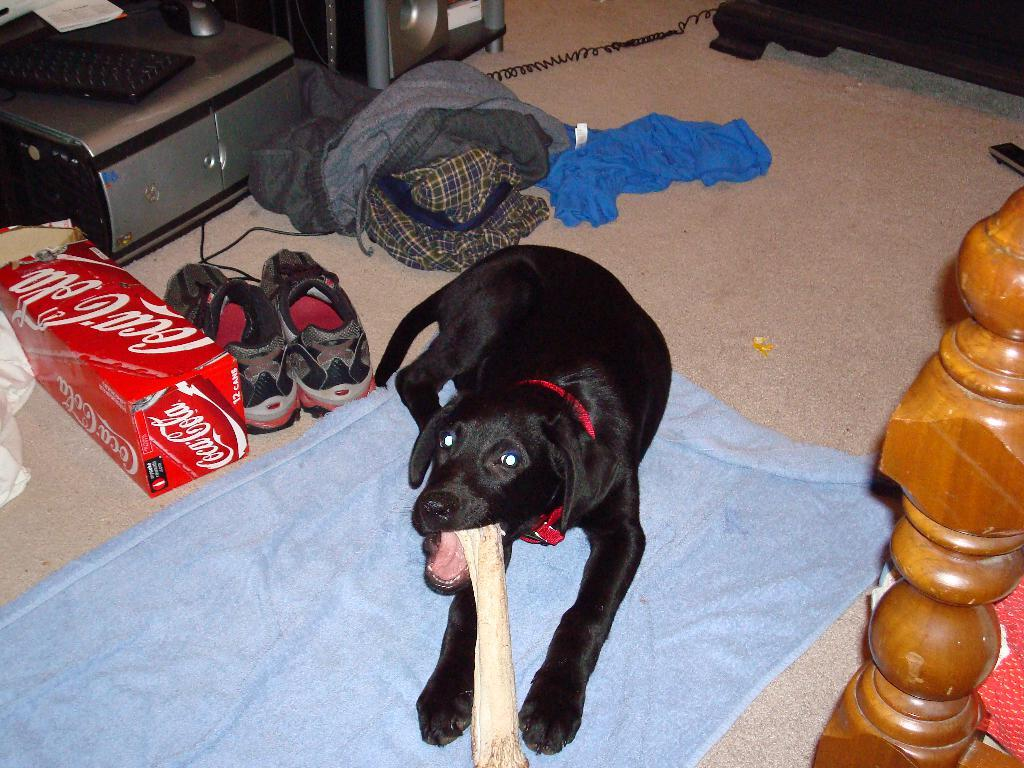What is the main subject in the center of the image? There is a black color dog in the center of the image. What items can be seen on the left side of the image? Shoes, clothing, a box, a CPU, a keyboard, and a speaker are visible on the left side of the image. What is present on the right side of the image? There is a cot on the right side of the image. Can you describe the objects on the left side of the image in more detail? The box, CPU, keyboard, and speaker are all related to technology and computing. How does the dog contribute to the growth of the plants in the image? There are no plants present in the image, so the dog's contribution to their growth cannot be determined. 